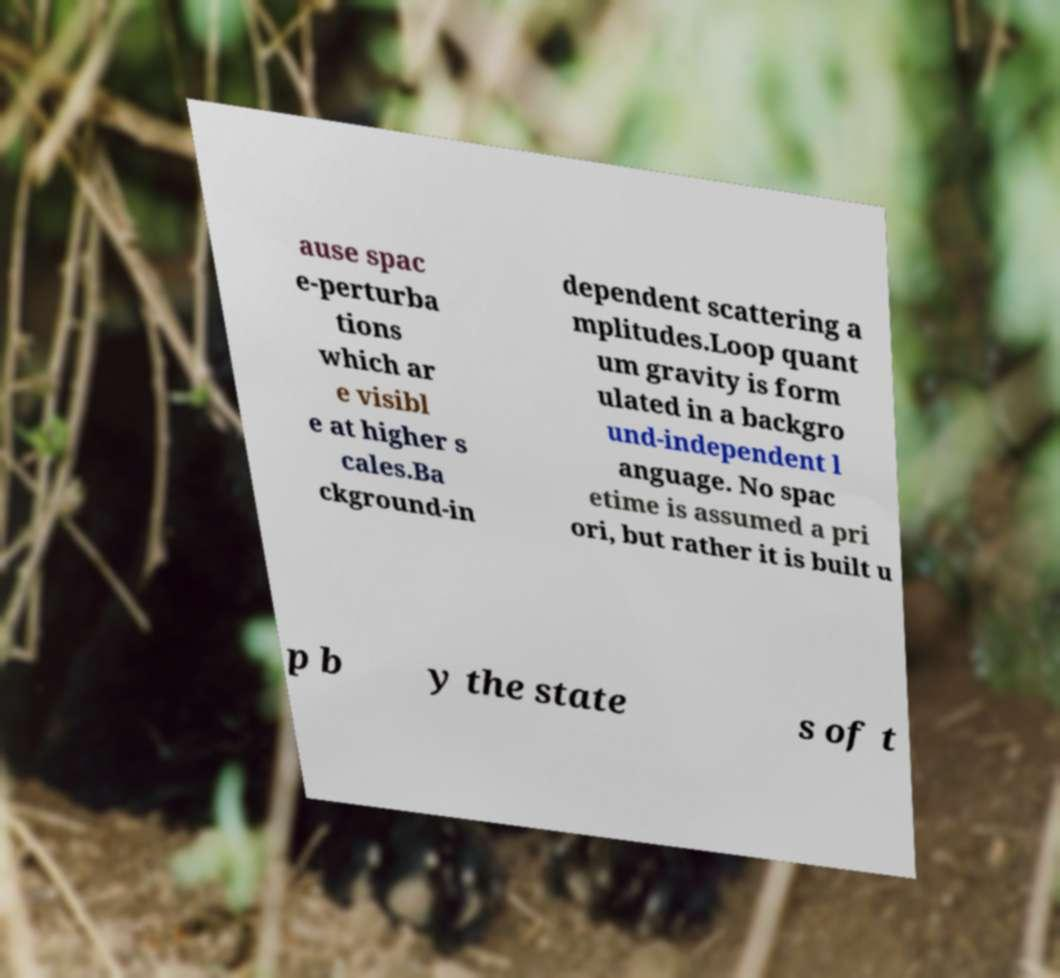Please read and relay the text visible in this image. What does it say? ause spac e-perturba tions which ar e visibl e at higher s cales.Ba ckground-in dependent scattering a mplitudes.Loop quant um gravity is form ulated in a backgro und-independent l anguage. No spac etime is assumed a pri ori, but rather it is built u p b y the state s of t 